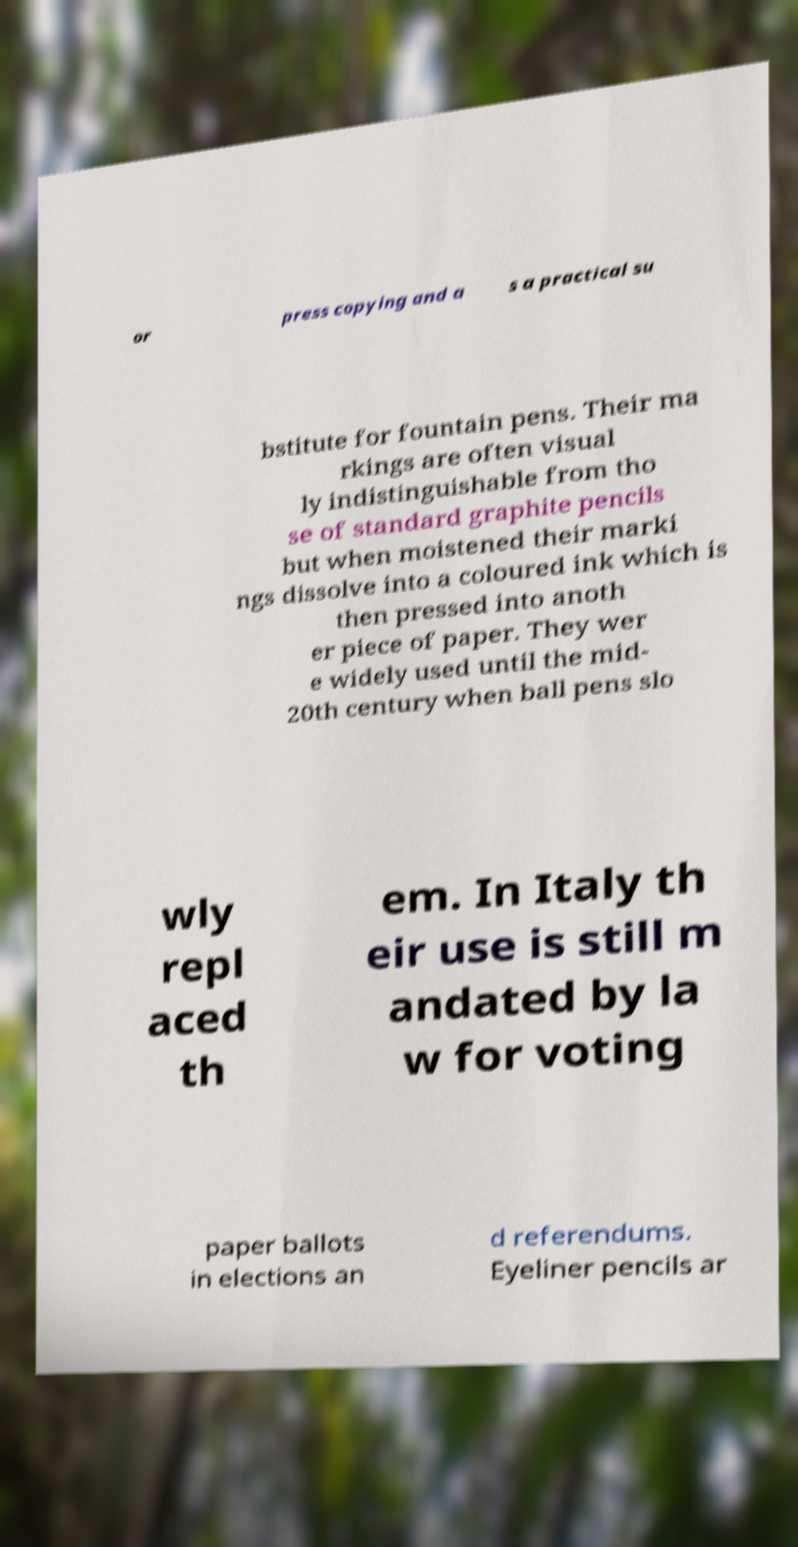Please identify and transcribe the text found in this image. or press copying and a s a practical su bstitute for fountain pens. Their ma rkings are often visual ly indistinguishable from tho se of standard graphite pencils but when moistened their marki ngs dissolve into a coloured ink which is then pressed into anoth er piece of paper. They wer e widely used until the mid- 20th century when ball pens slo wly repl aced th em. In Italy th eir use is still m andated by la w for voting paper ballots in elections an d referendums. Eyeliner pencils ar 